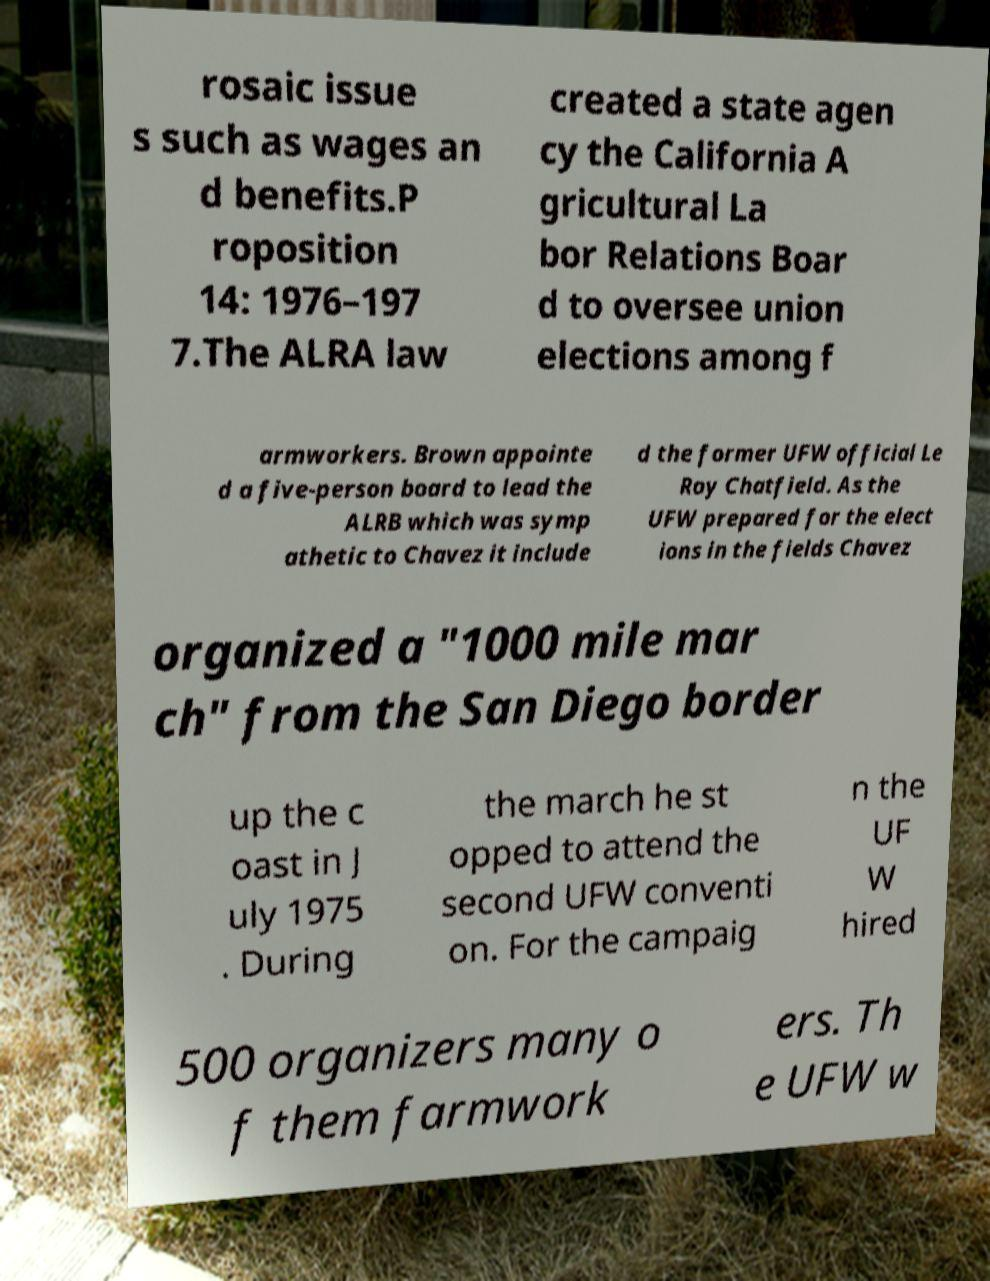Please identify and transcribe the text found in this image. rosaic issue s such as wages an d benefits.P roposition 14: 1976–197 7.The ALRA law created a state agen cy the California A gricultural La bor Relations Boar d to oversee union elections among f armworkers. Brown appointe d a five-person board to lead the ALRB which was symp athetic to Chavez it include d the former UFW official Le Roy Chatfield. As the UFW prepared for the elect ions in the fields Chavez organized a "1000 mile mar ch" from the San Diego border up the c oast in J uly 1975 . During the march he st opped to attend the second UFW conventi on. For the campaig n the UF W hired 500 organizers many o f them farmwork ers. Th e UFW w 